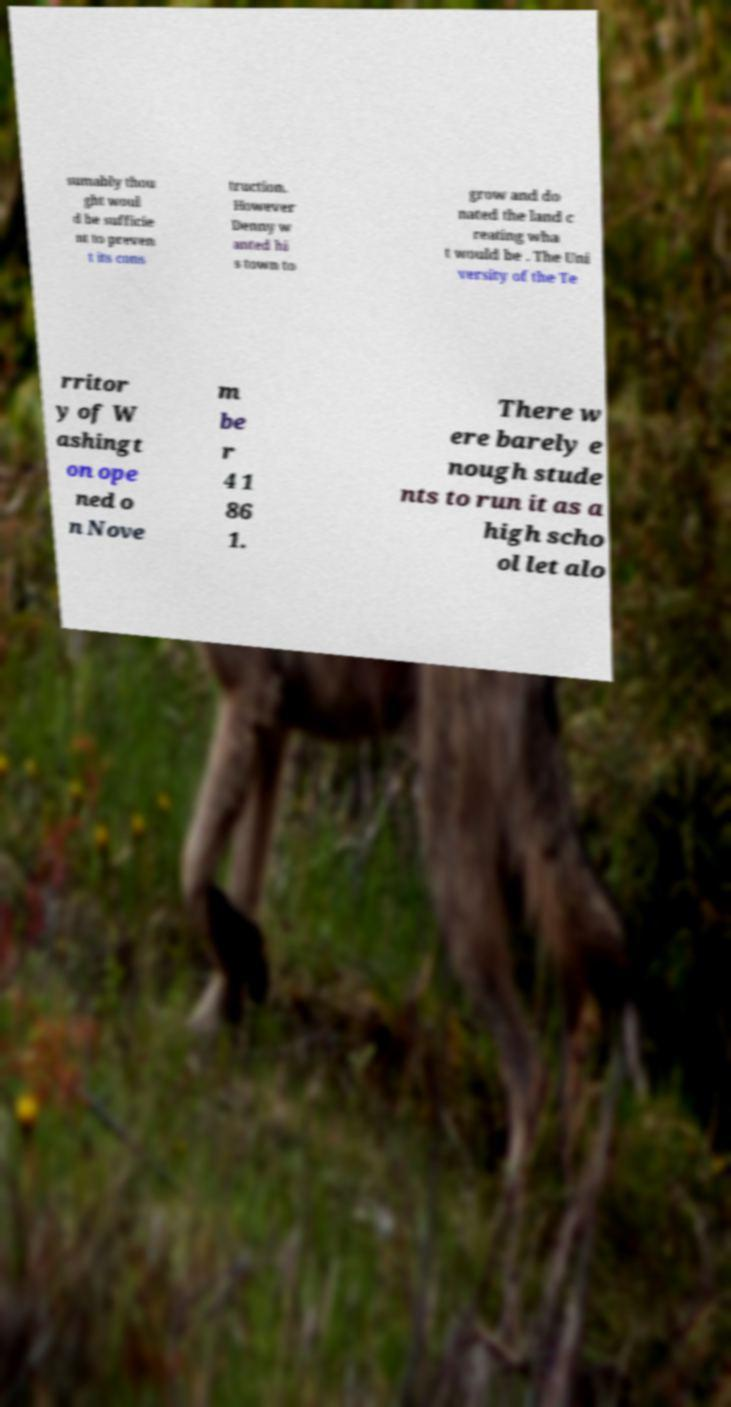Can you accurately transcribe the text from the provided image for me? sumably thou ght woul d be sufficie nt to preven t its cons truction. However Denny w anted hi s town to grow and do nated the land c reating wha t would be . The Uni versity of the Te rritor y of W ashingt on ope ned o n Nove m be r 4 1 86 1. There w ere barely e nough stude nts to run it as a high scho ol let alo 